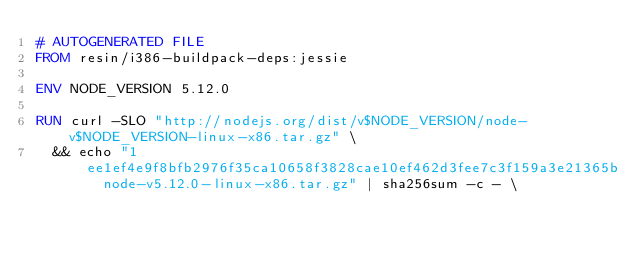Convert code to text. <code><loc_0><loc_0><loc_500><loc_500><_Dockerfile_># AUTOGENERATED FILE
FROM resin/i386-buildpack-deps:jessie

ENV NODE_VERSION 5.12.0

RUN curl -SLO "http://nodejs.org/dist/v$NODE_VERSION/node-v$NODE_VERSION-linux-x86.tar.gz" \
	&& echo "1ee1ef4e9f8bfb2976f35ca10658f3828cae10ef462d3fee7c3f159a3e21365b  node-v5.12.0-linux-x86.tar.gz" | sha256sum -c - \</code> 